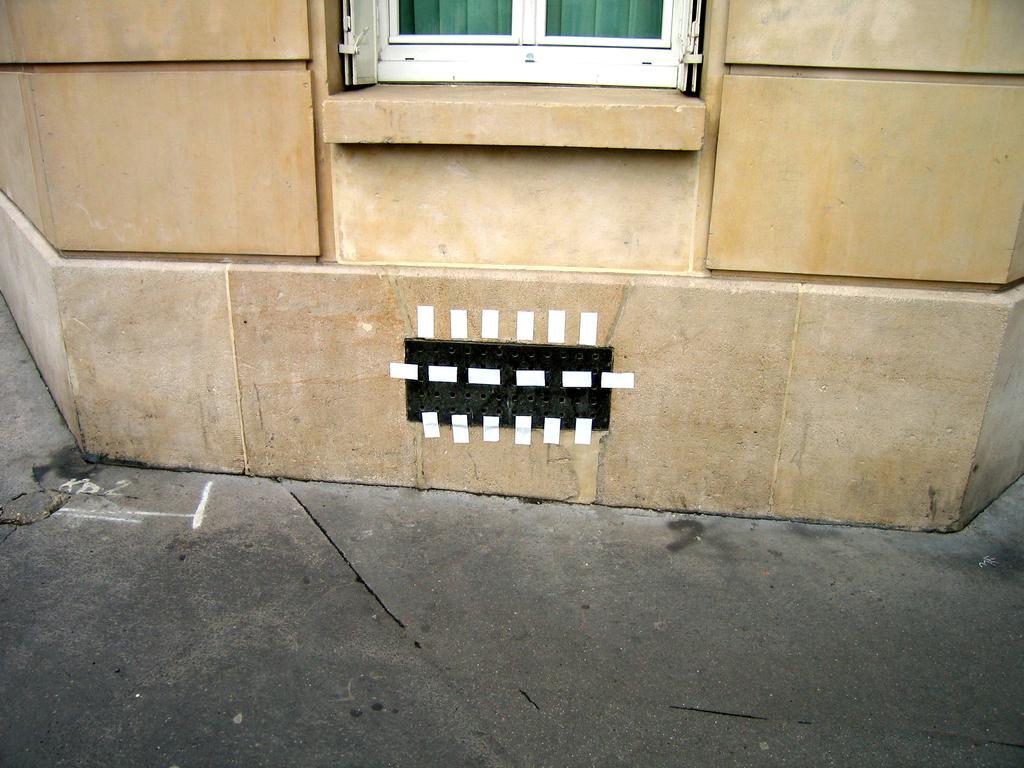Can you describe this image briefly? In this image we can see road, wall, and a window. 